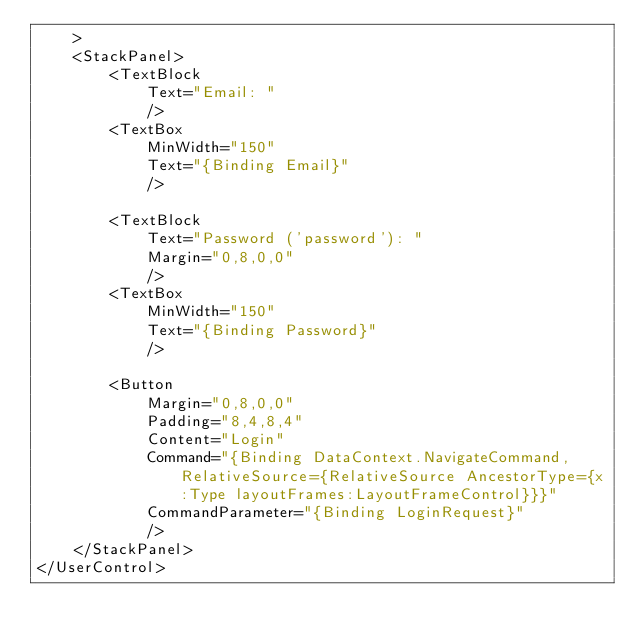<code> <loc_0><loc_0><loc_500><loc_500><_XML_>    >
    <StackPanel>
        <TextBlock
            Text="Email: "
            />
        <TextBox
            MinWidth="150"
            Text="{Binding Email}"
            />

        <TextBlock
            Text="Password ('password'): "
            Margin="0,8,0,0"
            />
        <TextBox
            MinWidth="150"
            Text="{Binding Password}"
            />

        <Button
            Margin="0,8,0,0"
            Padding="8,4,8,4"
            Content="Login"
            Command="{Binding DataContext.NavigateCommand, RelativeSource={RelativeSource AncestorType={x:Type layoutFrames:LayoutFrameControl}}}"
            CommandParameter="{Binding LoginRequest}"
            />
    </StackPanel>
</UserControl>
</code> 